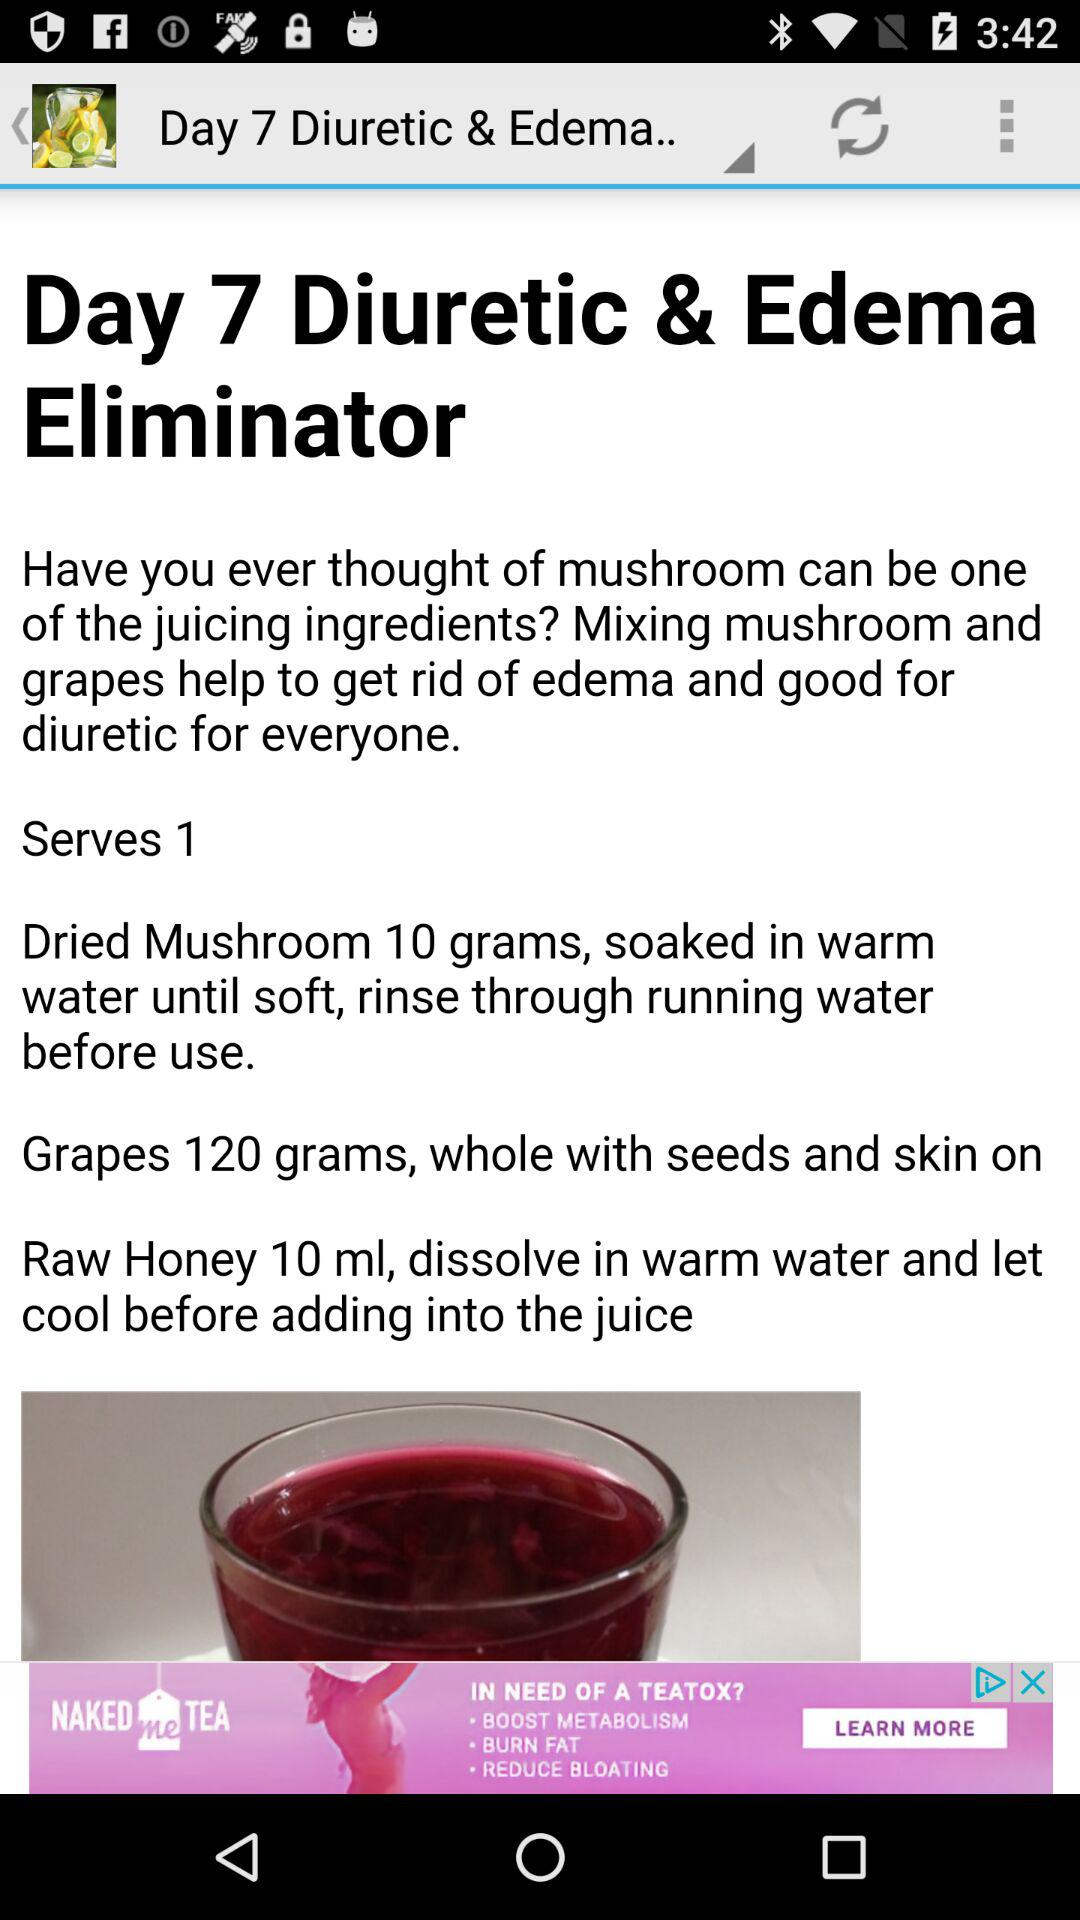How many more grams of grapes are needed than mushrooms?
Answer the question using a single word or phrase. 110 